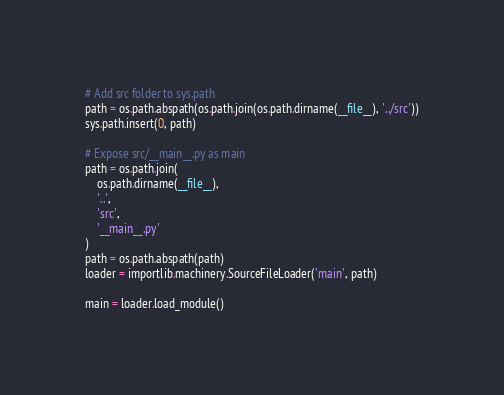<code> <loc_0><loc_0><loc_500><loc_500><_Python_>
# Add src folder to sys.path
path = os.path.abspath(os.path.join(os.path.dirname(__file__), '../src'))
sys.path.insert(0, path)

# Expose src/__main__.py as main
path = os.path.join(
    os.path.dirname(__file__),
    '..',
    'src',
    '__main__.py'
)
path = os.path.abspath(path)
loader = importlib.machinery.SourceFileLoader('main', path)

main = loader.load_module()
</code> 